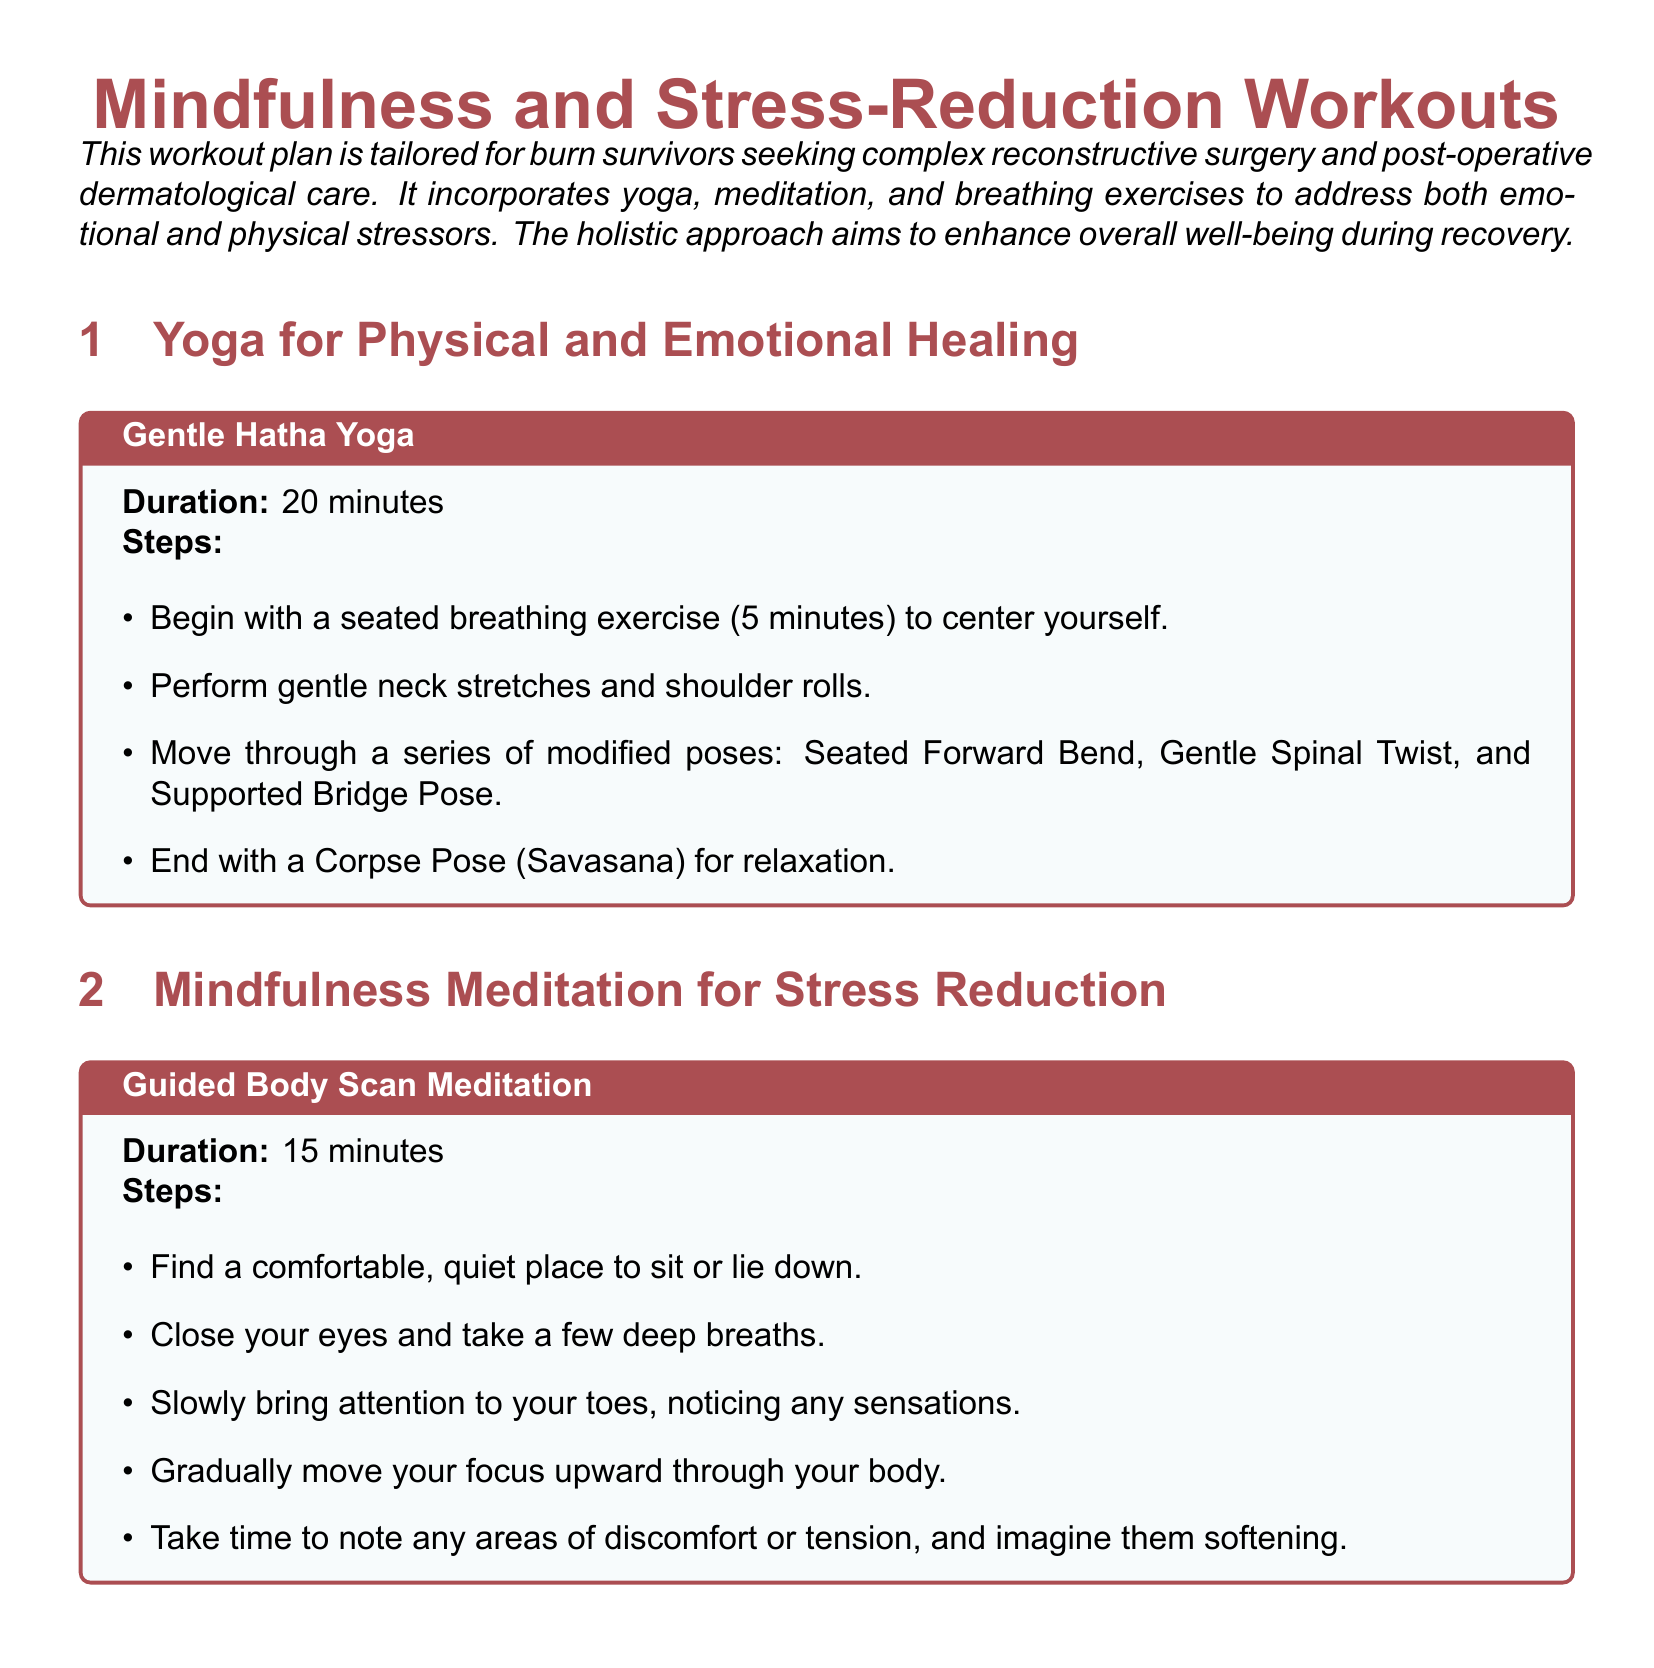What is the duration of Gentle Hatha Yoga? The duration is specified at the beginning of the exercise section for Gentle Hatha Yoga.
Answer: 20 minutes What breathing technique is detailed for relaxation? The document lists the specific technique used for relaxation, which is described in the breathing exercises section.
Answer: 4-7-8 Breathing Technique How many minutes should be dedicated to Gratitude Journaling? The time allocated for Gratitude Journaling is stated in its exercise box.
Answer: 10 minutes What is the purpose of the Mindfulness and Stress-Reduction Workouts? The document outlines the overall aim of these workouts at the beginning of the introduction.
Answer: Enhance overall well-being during recovery Which posture is the last in the Gentle Hatha Yoga routine? The last posture mentioned in the Gentle Hatha Yoga section is the final resting pose.
Answer: Corpse Pose (Savasana) What type of journaling is suggested as a stress-relief strategy? This strategy is specified in the stress-relief strategies section.
Answer: Gratitude Journaling How many times should the 4-7-8 Breathing Technique cycle be repeated? The document specifies the number of cycles to be performed during this breathing exercise.
Answer: 4 times What is the first step in the Guided Body Scan Meditation? The first step introduces the setting for the meditation practice.
Answer: Find a comfortable, quiet place to sit or lie down What should you include in your gratitude list? The document suggests specific content to write in the gratitude journaling exercise.
Answer: 3-5 things you're grateful for 